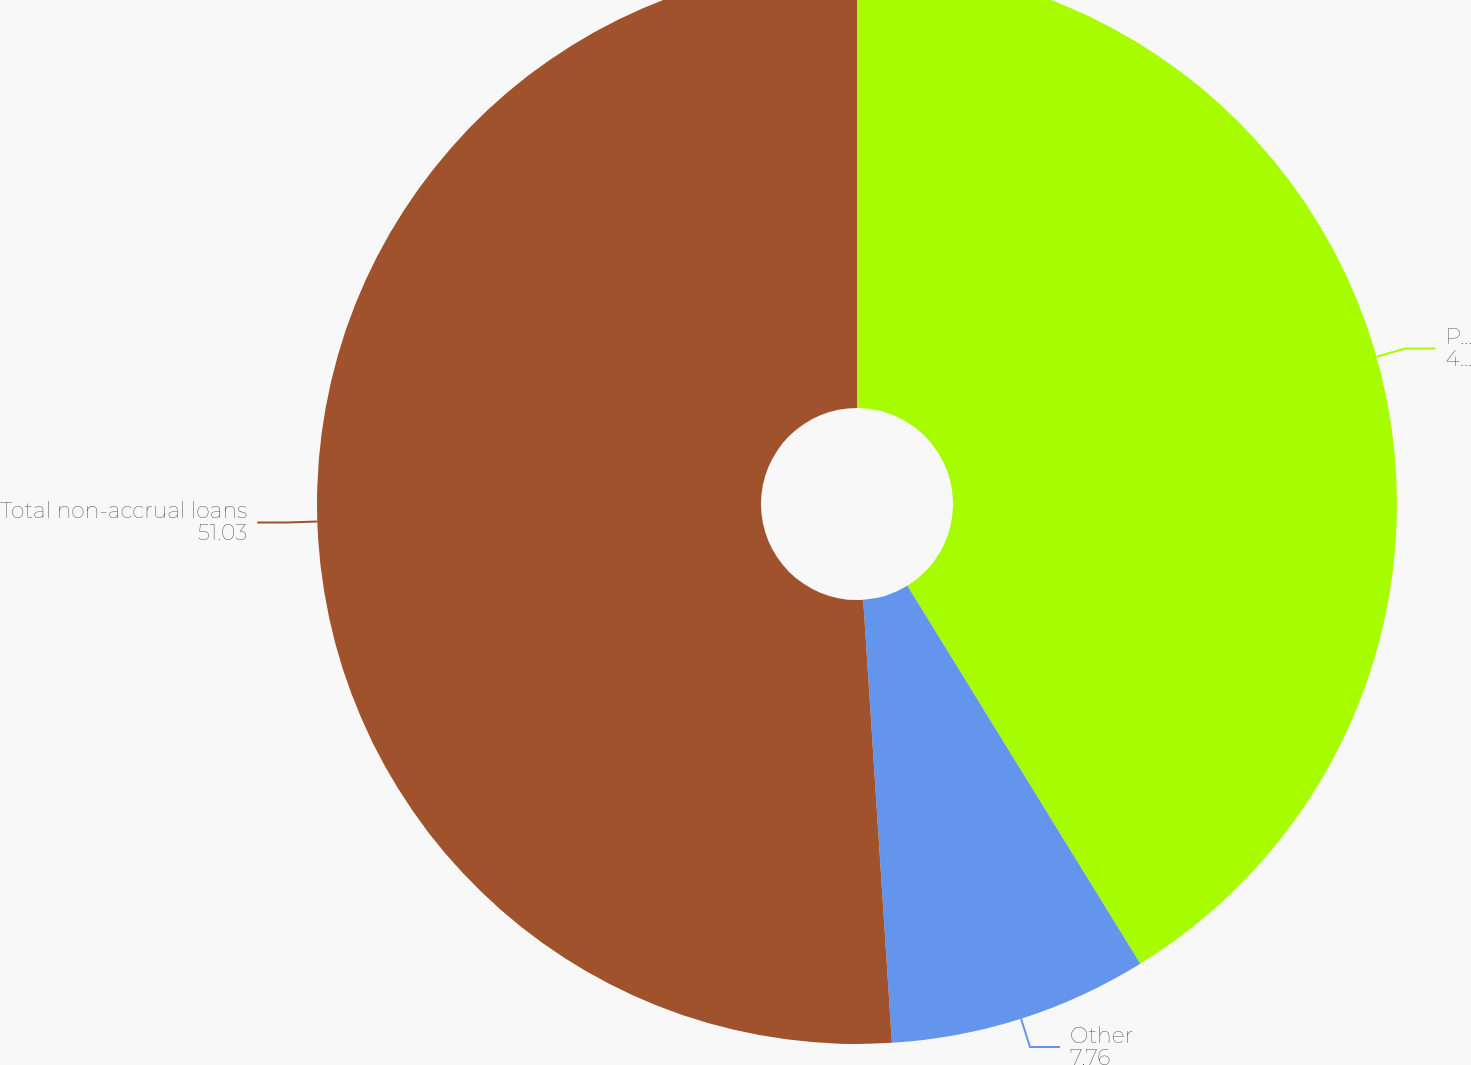Convert chart. <chart><loc_0><loc_0><loc_500><loc_500><pie_chart><fcel>Purchased from SCC<fcel>Other<fcel>Total non-accrual loans<nl><fcel>41.21%<fcel>7.76%<fcel>51.03%<nl></chart> 